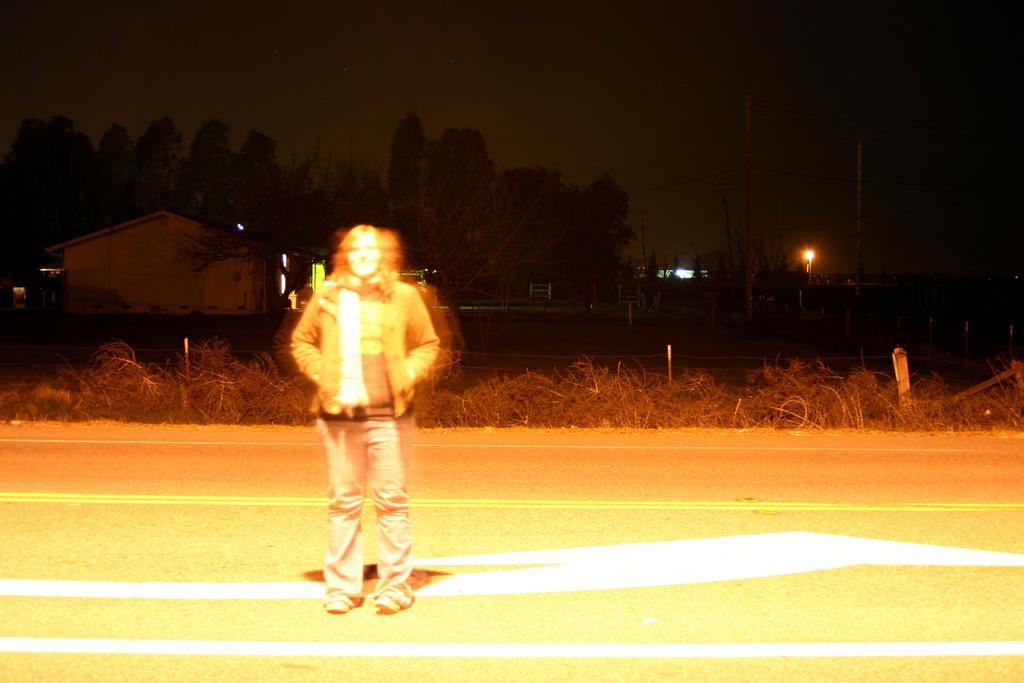Could you give a brief overview of what you see in this image? In this picture we can see a woman standing on the road and at the back of her we can see plants, buildings, poles, trees, lights, some objects and in the background we can see the sky. 